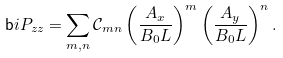Convert formula to latex. <formula><loc_0><loc_0><loc_500><loc_500>\mathsf b i { P } _ { z z } = \sum _ { m , n } \mathcal { C } _ { m n } \left ( \frac { A _ { x } } { B _ { 0 } L } \right ) ^ { m } \left ( \frac { A _ { y } } { B _ { 0 } L } \right ) ^ { n } .</formula> 